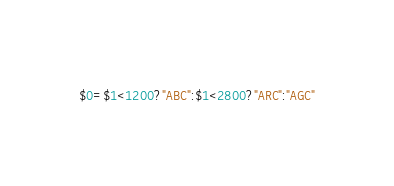Convert code to text. <code><loc_0><loc_0><loc_500><loc_500><_Awk_>$0=$1<1200?"ABC":$1<2800?"ARC":"AGC"</code> 